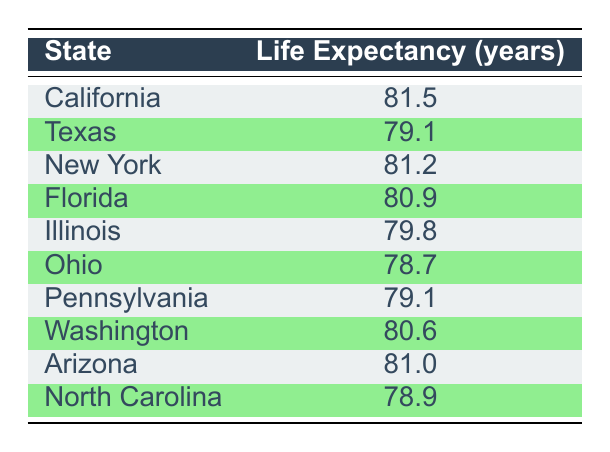What is the life expectancy in California? The table lists California's life expectancy under the respective column, which is 81.5 years.
Answer: 81.5 Which state has a life expectancy of 78.7 years? Looking through the table, Ohio is the state listed with a life expectancy of 78.7 years.
Answer: Ohio What is the difference in life expectancy between Texas and Florida? Texas has a life expectancy of 79.1 years, while Florida has 80.9 years. Calculating the difference: 80.9 - 79.1 = 1.8 years.
Answer: 1.8 Is the life expectancy in Arizona greater than that in North Carolina? Arizona has a life expectancy of 81.0 years, and North Carolina has 78.9 years. Since 81.0 > 78.9, the statement is true.
Answer: Yes What is the average life expectancy of New York and Pennsylvania? Adding the life expectancy of New York (81.2) and Pennsylvania (79.1) gives us a total of 160.3. Dividing by 2 for the average: 160.3 / 2 = 80.15.
Answer: 80.15 Which two states have the lowest life expectancy, and what are their values? By reviewing the table, Illinois has 79.8 years, and Ohio has 78.7 years, making them the two states with the lowest life expectancy.
Answer: Ohio (78.7) and Illinois (79.8) Is it true that all states listed have a life expectancy above 78 years? The lowest life expectancy from the table is 78.7 years in Ohio. Since it is above 78 years, this statement is true for all states in the table.
Answer: Yes What is the average life expectancy of all the listed states? First, adding the life expectancies of all states: (81.5 + 79.1 + 81.2 + 80.9 + 79.8 + 78.7 + 79.1 + 80.6 + 81.0 + 78.9) = 800.8. Since there are 10 states, the average is 800.8 / 10 = 80.08 years.
Answer: 80.08 